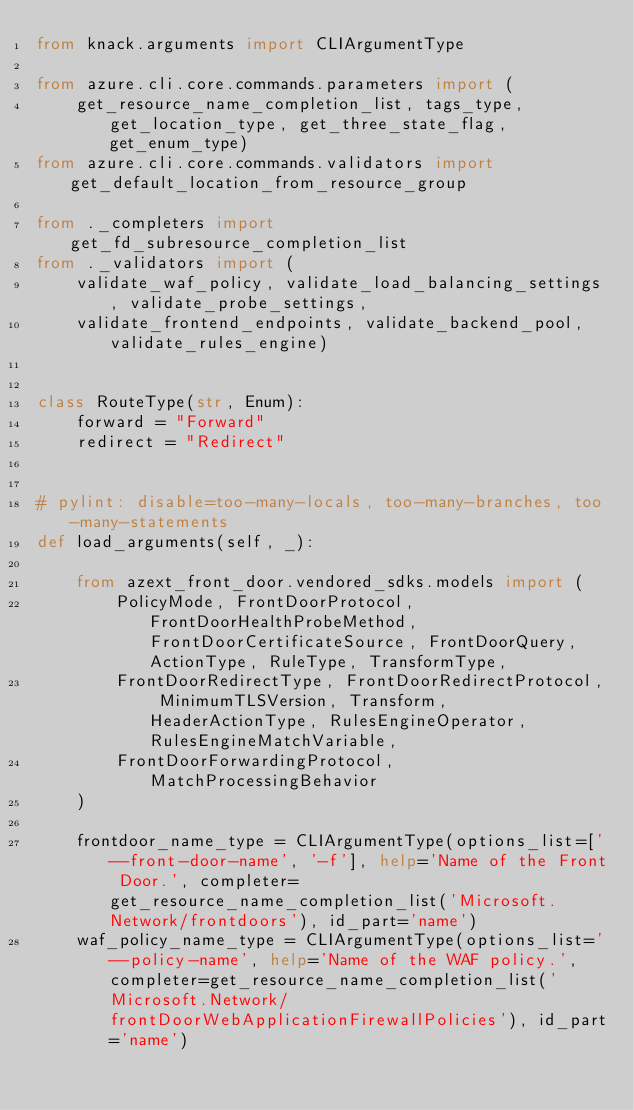Convert code to text. <code><loc_0><loc_0><loc_500><loc_500><_Python_>from knack.arguments import CLIArgumentType

from azure.cli.core.commands.parameters import (
    get_resource_name_completion_list, tags_type, get_location_type, get_three_state_flag, get_enum_type)
from azure.cli.core.commands.validators import get_default_location_from_resource_group

from ._completers import get_fd_subresource_completion_list
from ._validators import (
    validate_waf_policy, validate_load_balancing_settings, validate_probe_settings,
    validate_frontend_endpoints, validate_backend_pool, validate_rules_engine)


class RouteType(str, Enum):
    forward = "Forward"
    redirect = "Redirect"


# pylint: disable=too-many-locals, too-many-branches, too-many-statements
def load_arguments(self, _):

    from azext_front_door.vendored_sdks.models import (
        PolicyMode, FrontDoorProtocol, FrontDoorHealthProbeMethod, FrontDoorCertificateSource, FrontDoorQuery, ActionType, RuleType, TransformType,
        FrontDoorRedirectType, FrontDoorRedirectProtocol, MinimumTLSVersion, Transform, HeaderActionType, RulesEngineOperator, RulesEngineMatchVariable,
        FrontDoorForwardingProtocol, MatchProcessingBehavior
    )

    frontdoor_name_type = CLIArgumentType(options_list=['--front-door-name', '-f'], help='Name of the Front Door.', completer=get_resource_name_completion_list('Microsoft.Network/frontdoors'), id_part='name')
    waf_policy_name_type = CLIArgumentType(options_list='--policy-name', help='Name of the WAF policy.', completer=get_resource_name_completion_list('Microsoft.Network/frontDoorWebApplicationFirewallPolicies'), id_part='name')</code> 